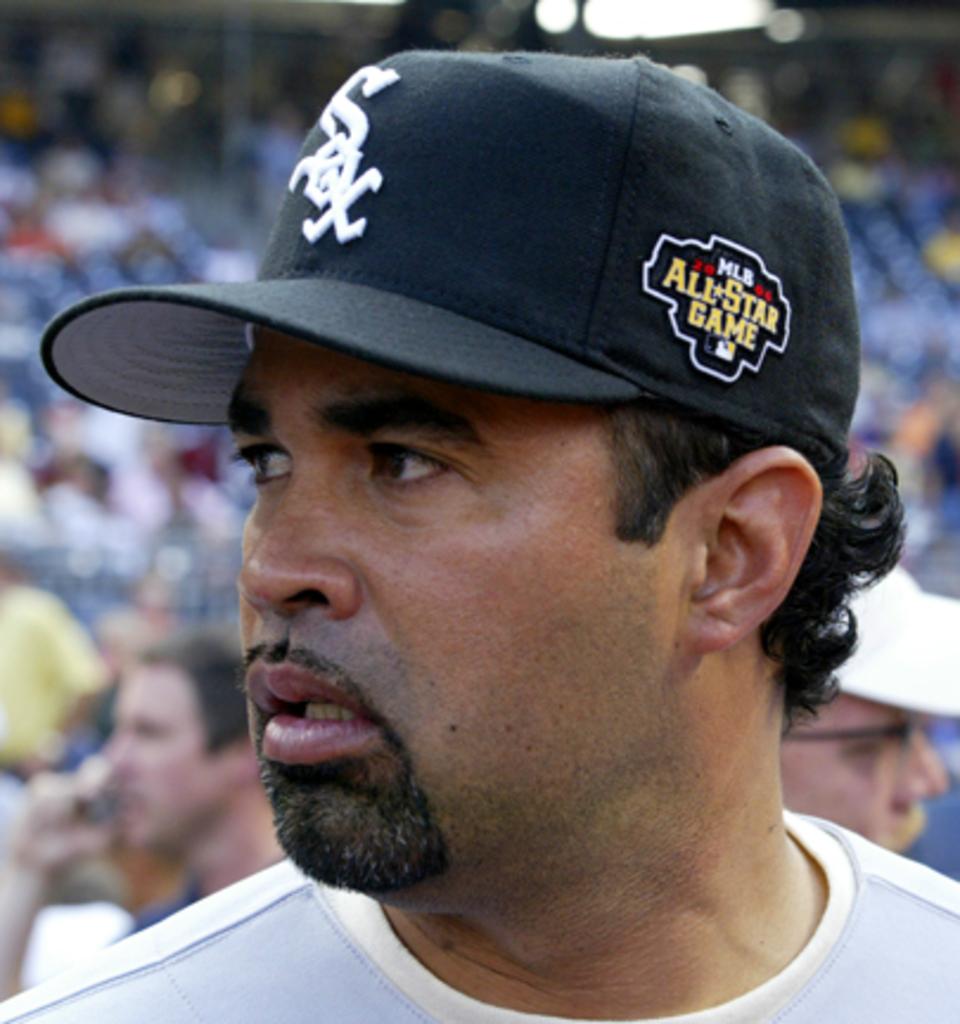What is the name of the team on man's hat?
Ensure brevity in your answer.  Sox. What color is the man's hat?
Your answer should be very brief. Answering does not require reading text in the image. 